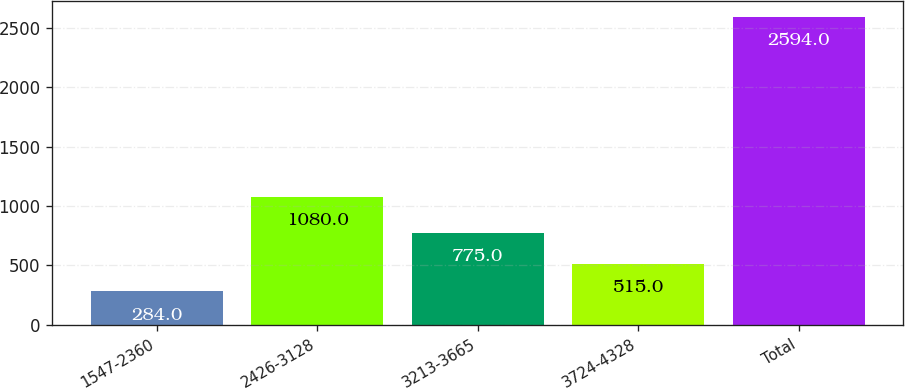Convert chart to OTSL. <chart><loc_0><loc_0><loc_500><loc_500><bar_chart><fcel>1547-2360<fcel>2426-3128<fcel>3213-3665<fcel>3724-4328<fcel>Total<nl><fcel>284<fcel>1080<fcel>775<fcel>515<fcel>2594<nl></chart> 